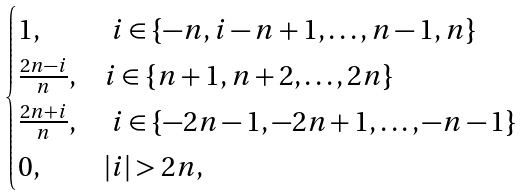Convert formula to latex. <formula><loc_0><loc_0><loc_500><loc_500>\begin{cases} 1 , & \ i \in \{ - n , i - n + 1 , \dots , n - 1 , n \} \\ \frac { 2 n - i } { n } , & i \in \{ n + 1 , n + 2 , \dots , 2 n \} \\ \frac { 2 n + i } { n } , & \ i \in \{ - 2 n - 1 , - 2 n + 1 , \dots , - n - 1 \} \\ 0 , & | i | > 2 n , \end{cases}</formula> 